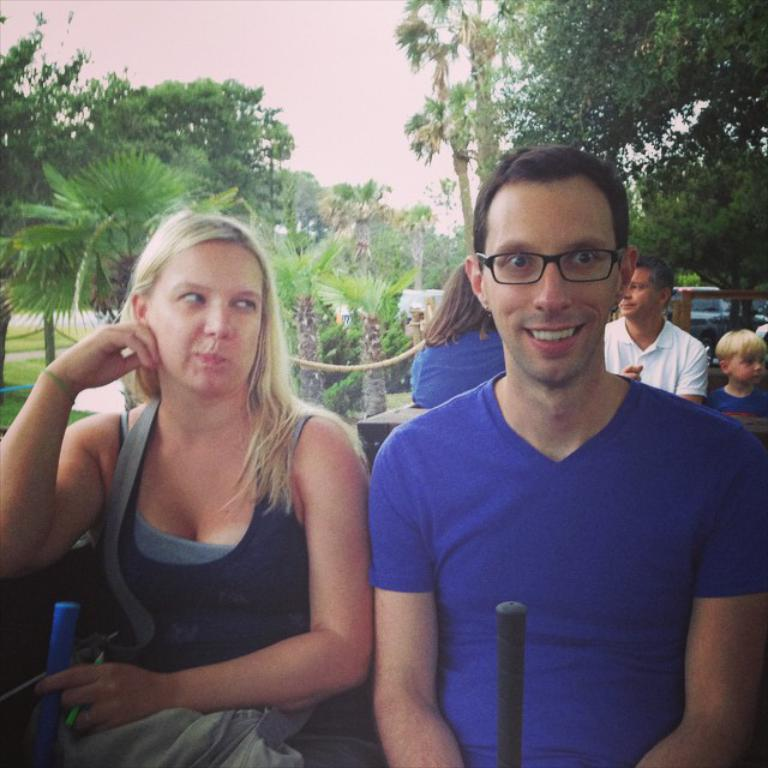How many people are present in the image? There are two people, a woman and a man, present in the image. What is the expression of the man in the image? The man is smiling in the image. What accessory is the man wearing? The man is wearing spectacles in the image. What can be seen in the background of the image? There are people, trees, and the sky visible in the background of the image. What type of creature is demanding attention in the image? There is no creature present in the image, and therefore no such demand for attention can be observed. 